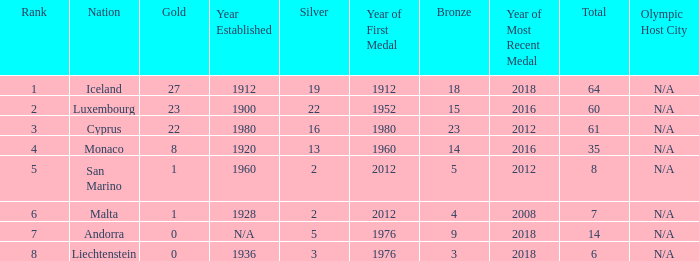How many golds for the nation with 14 total? 0.0. 